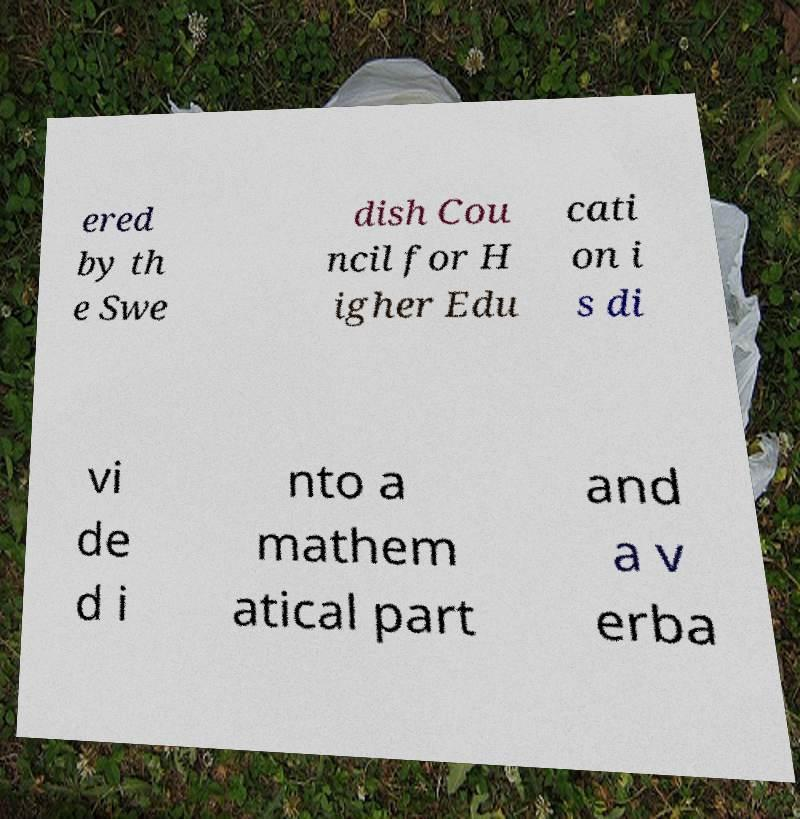What messages or text are displayed in this image? I need them in a readable, typed format. ered by th e Swe dish Cou ncil for H igher Edu cati on i s di vi de d i nto a mathem atical part and a v erba 